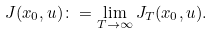Convert formula to latex. <formula><loc_0><loc_0><loc_500><loc_500>J ( x _ { 0 } , u ) \colon = \lim _ { T \rightarrow \infty } J _ { T } ( x _ { 0 } , u ) .</formula> 